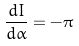<formula> <loc_0><loc_0><loc_500><loc_500>\frac { d I } { d \alpha } = - \pi</formula> 